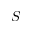Convert formula to latex. <formula><loc_0><loc_0><loc_500><loc_500>S</formula> 